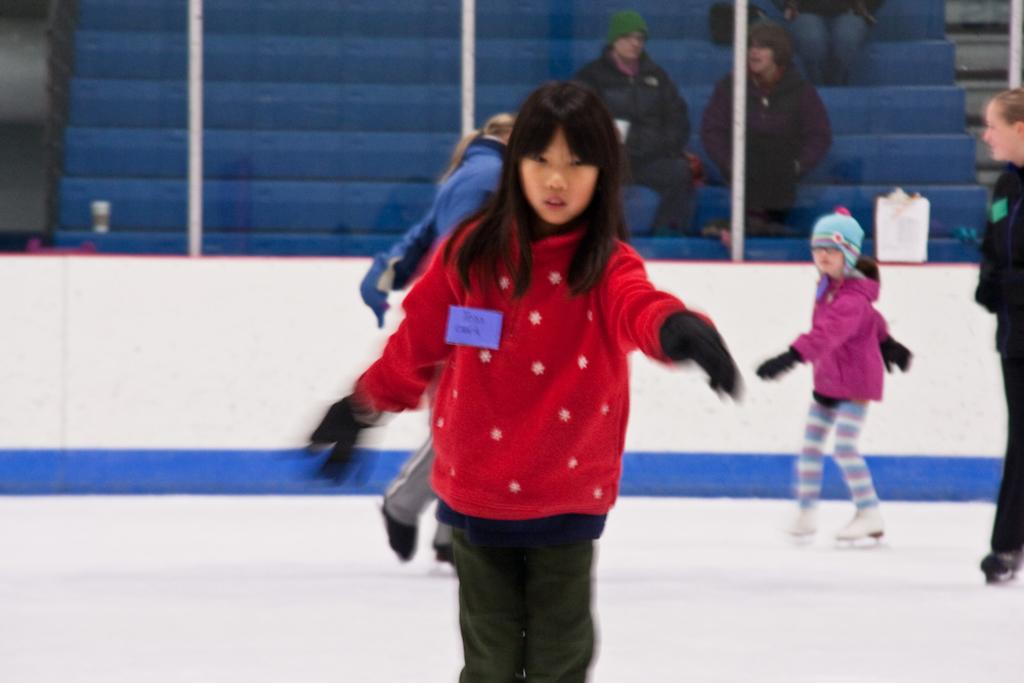What activity are the people in the image engaged in? A: The people in the image are skating on the floor. Can you describe another group of people in the image? There are people sitting on a staircase in the image. What type of twist can be seen in the image? There is no twist present in the image; it features people skating on the floor and others sitting on a staircase. 